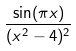Convert formula to latex. <formula><loc_0><loc_0><loc_500><loc_500>\frac { \sin ( \pi x ) } { ( x ^ { 2 } - 4 ) ^ { 2 } }</formula> 